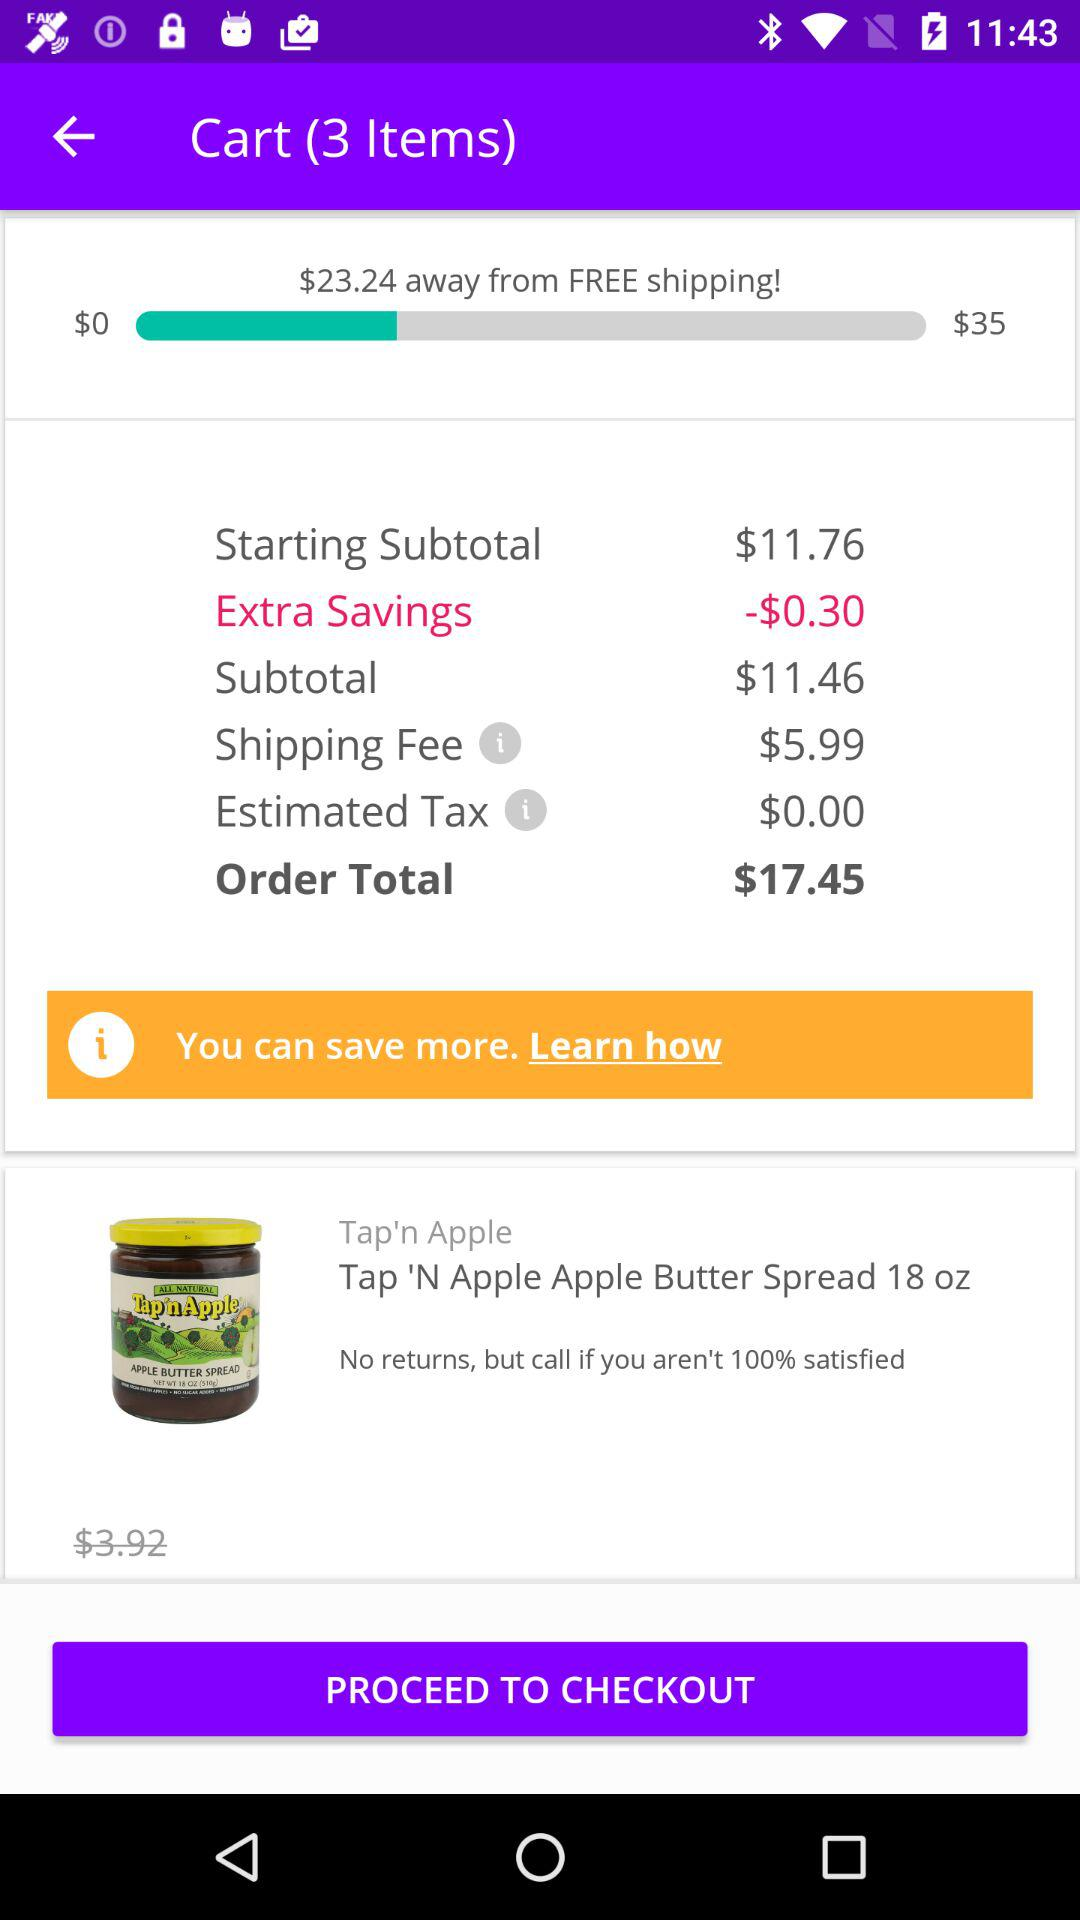What fee has a price of $5.99? The $5.99 price is for shipping. 